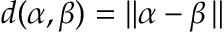Convert formula to latex. <formula><loc_0><loc_0><loc_500><loc_500>d ( \alpha , \beta ) = \| \alpha - \beta \, \|</formula> 